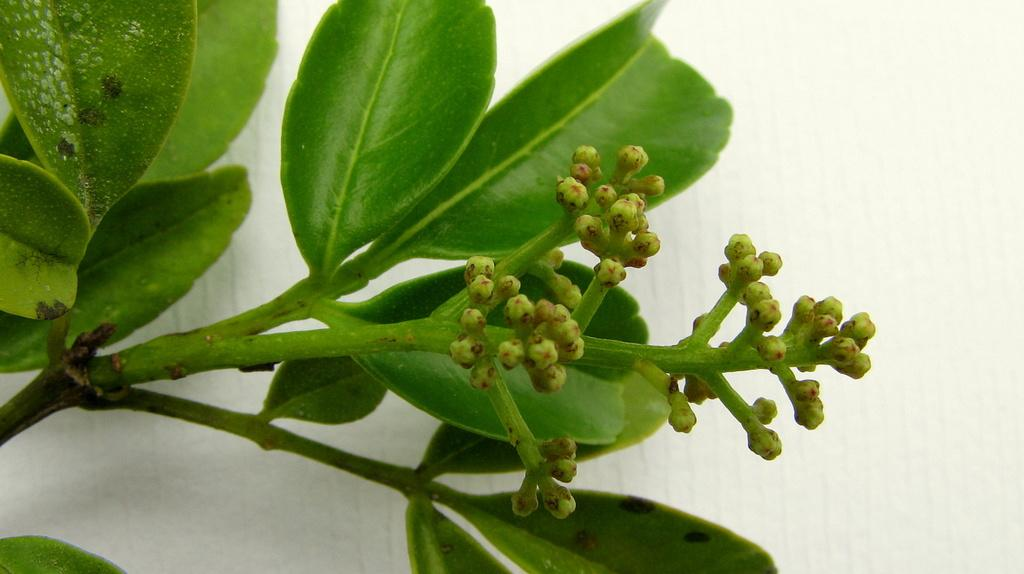What type of plant material is present in the image? There are green leaves, stems, and buds in the image. What can be seen in the background of the image? There is a white wall in the background of the image. Where is the toothpaste located in the image? There is no toothpaste present in the image. What type of throne can be seen in the image? There is no throne present in the image. 